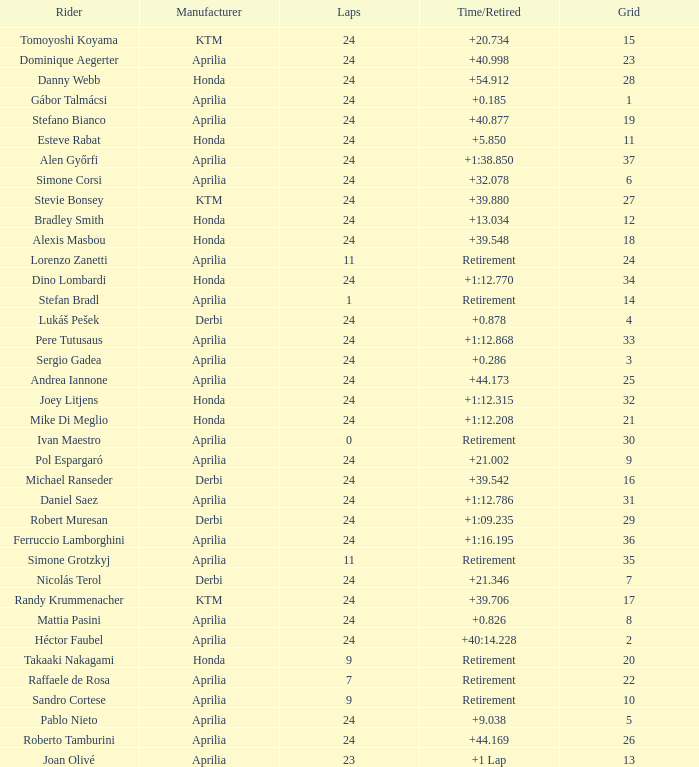How many grids have more than 24 laps with a time/retired of +1:12.208? None. I'm looking to parse the entire table for insights. Could you assist me with that? {'header': ['Rider', 'Manufacturer', 'Laps', 'Time/Retired', 'Grid'], 'rows': [['Tomoyoshi Koyama', 'KTM', '24', '+20.734', '15'], ['Dominique Aegerter', 'Aprilia', '24', '+40.998', '23'], ['Danny Webb', 'Honda', '24', '+54.912', '28'], ['Gábor Talmácsi', 'Aprilia', '24', '+0.185', '1'], ['Stefano Bianco', 'Aprilia', '24', '+40.877', '19'], ['Esteve Rabat', 'Honda', '24', '+5.850', '11'], ['Alen Győrfi', 'Aprilia', '24', '+1:38.850', '37'], ['Simone Corsi', 'Aprilia', '24', '+32.078', '6'], ['Stevie Bonsey', 'KTM', '24', '+39.880', '27'], ['Bradley Smith', 'Honda', '24', '+13.034', '12'], ['Alexis Masbou', 'Honda', '24', '+39.548', '18'], ['Lorenzo Zanetti', 'Aprilia', '11', 'Retirement', '24'], ['Dino Lombardi', 'Honda', '24', '+1:12.770', '34'], ['Stefan Bradl', 'Aprilia', '1', 'Retirement', '14'], ['Lukáš Pešek', 'Derbi', '24', '+0.878', '4'], ['Pere Tutusaus', 'Aprilia', '24', '+1:12.868', '33'], ['Sergio Gadea', 'Aprilia', '24', '+0.286', '3'], ['Andrea Iannone', 'Aprilia', '24', '+44.173', '25'], ['Joey Litjens', 'Honda', '24', '+1:12.315', '32'], ['Mike Di Meglio', 'Honda', '24', '+1:12.208', '21'], ['Ivan Maestro', 'Aprilia', '0', 'Retirement', '30'], ['Pol Espargaró', 'Aprilia', '24', '+21.002', '9'], ['Michael Ranseder', 'Derbi', '24', '+39.542', '16'], ['Daniel Saez', 'Aprilia', '24', '+1:12.786', '31'], ['Robert Muresan', 'Derbi', '24', '+1:09.235', '29'], ['Ferruccio Lamborghini', 'Aprilia', '24', '+1:16.195', '36'], ['Simone Grotzkyj', 'Aprilia', '11', 'Retirement', '35'], ['Nicolás Terol', 'Derbi', '24', '+21.346', '7'], ['Randy Krummenacher', 'KTM', '24', '+39.706', '17'], ['Mattia Pasini', 'Aprilia', '24', '+0.826', '8'], ['Héctor Faubel', 'Aprilia', '24', '+40:14.228', '2'], ['Takaaki Nakagami', 'Honda', '9', 'Retirement', '20'], ['Raffaele de Rosa', 'Aprilia', '7', 'Retirement', '22'], ['Sandro Cortese', 'Aprilia', '9', 'Retirement', '10'], ['Pablo Nieto', 'Aprilia', '24', '+9.038', '5'], ['Roberto Tamburini', 'Aprilia', '24', '+44.169', '26'], ['Joan Olivé', 'Aprilia', '23', '+1 Lap', '13']]} 